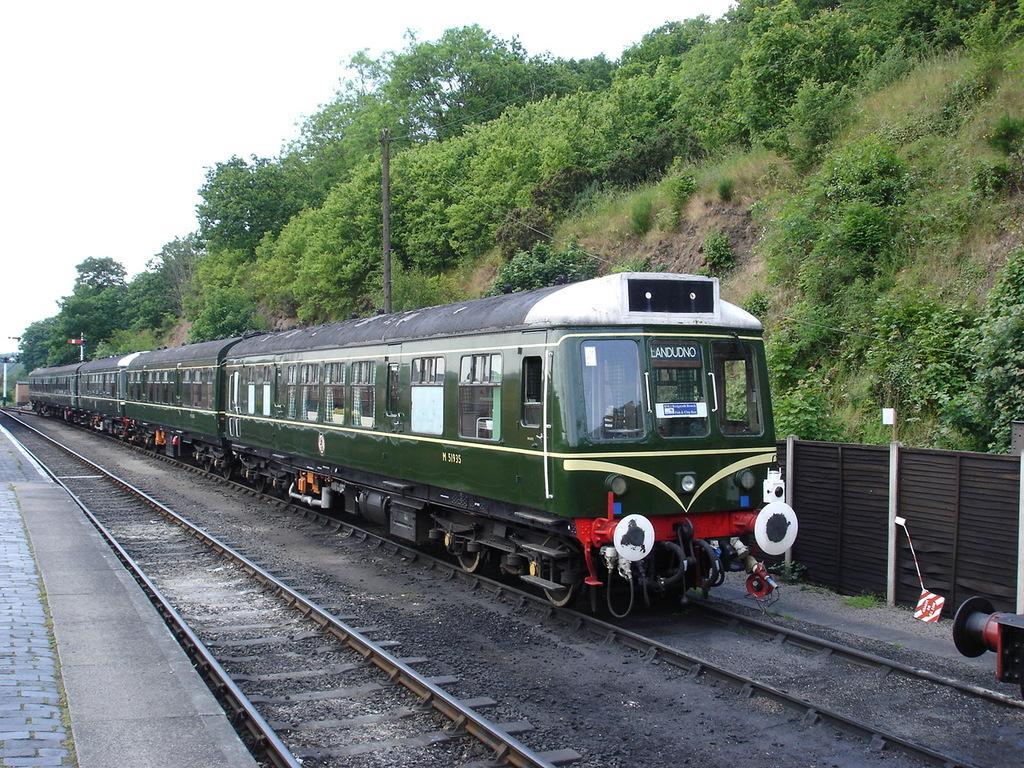How would you summarize this image in a sentence or two? In this image we can see the train on the track, beside this track there is another track and path. In the background there is a fencing, poles, trees and the sky. 